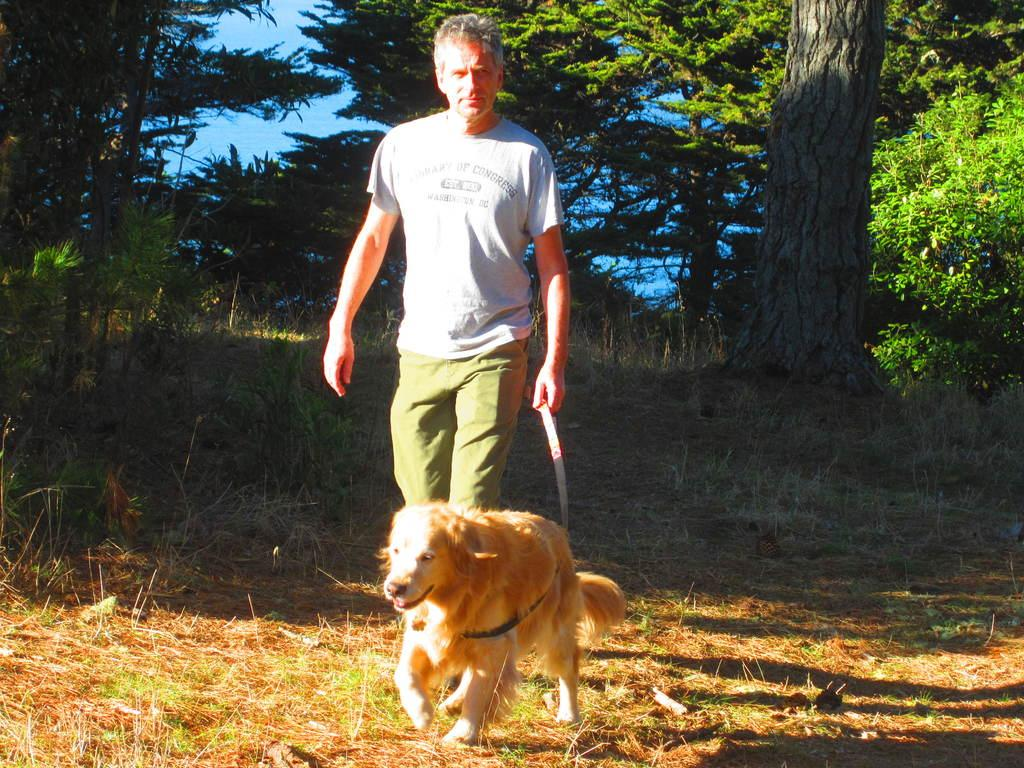Who is in the image? There is a man in the image. What is the man doing with the dog? The man is walking with a dog and catching the dog's belt. What can be seen in the background of the image? There are trees in the background of the image. What is the ground made of in the image? There is grass on the ground in the image. What type of vein is visible on the man's boot in the image? There is no boot or vein present in the image; the man is wearing shoes and walking with a dog. 